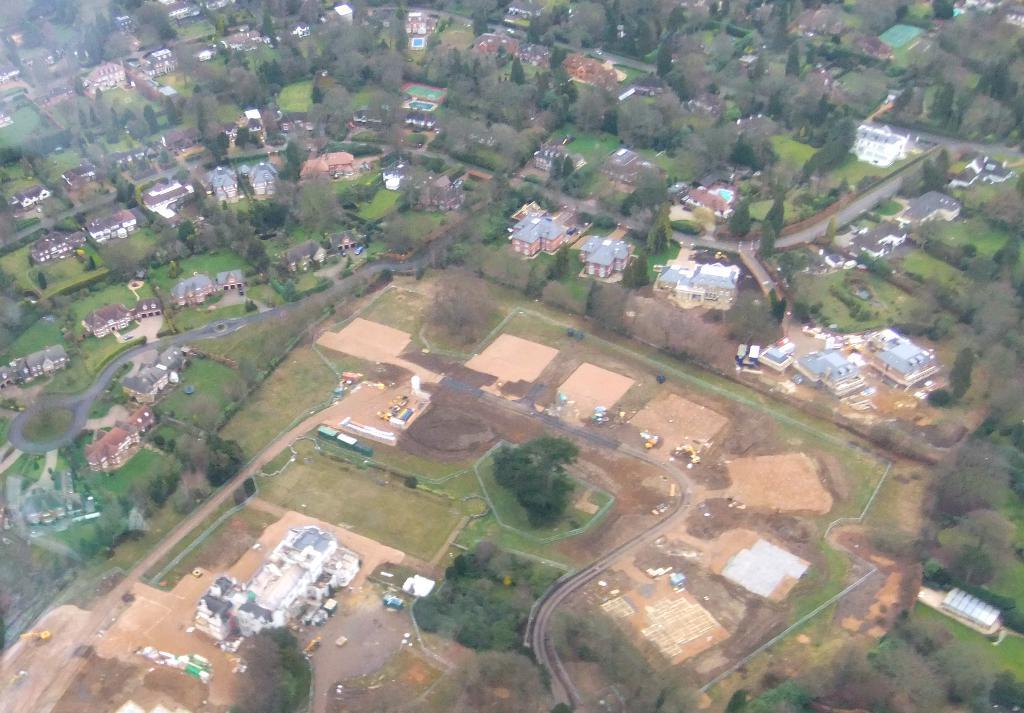What type of man-made structures can be seen in the image? There are buildings in the image. What type of natural elements can be seen in the image? There are trees in the image. What type of infrastructure is visible in the image? There are roads in the image. What type of drum can be seen in the image? There is no drum present in the image. Can you tell me how many pairs of scissors are visible in the image? There are no scissors present in the image. 